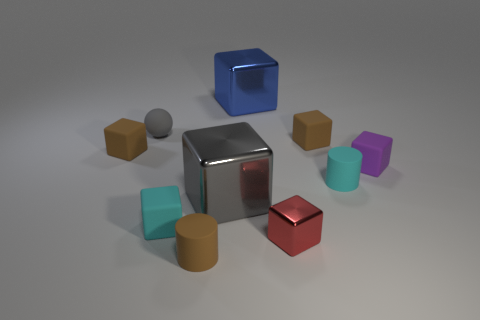Subtract all tiny purple rubber blocks. How many blocks are left? 6 Subtract all brown blocks. How many blocks are left? 5 Subtract all yellow blocks. Subtract all green spheres. How many blocks are left? 7 Subtract all blocks. How many objects are left? 3 Subtract all blue things. Subtract all matte blocks. How many objects are left? 5 Add 9 tiny purple matte blocks. How many tiny purple matte blocks are left? 10 Add 1 purple matte things. How many purple matte things exist? 2 Subtract 0 blue balls. How many objects are left? 10 